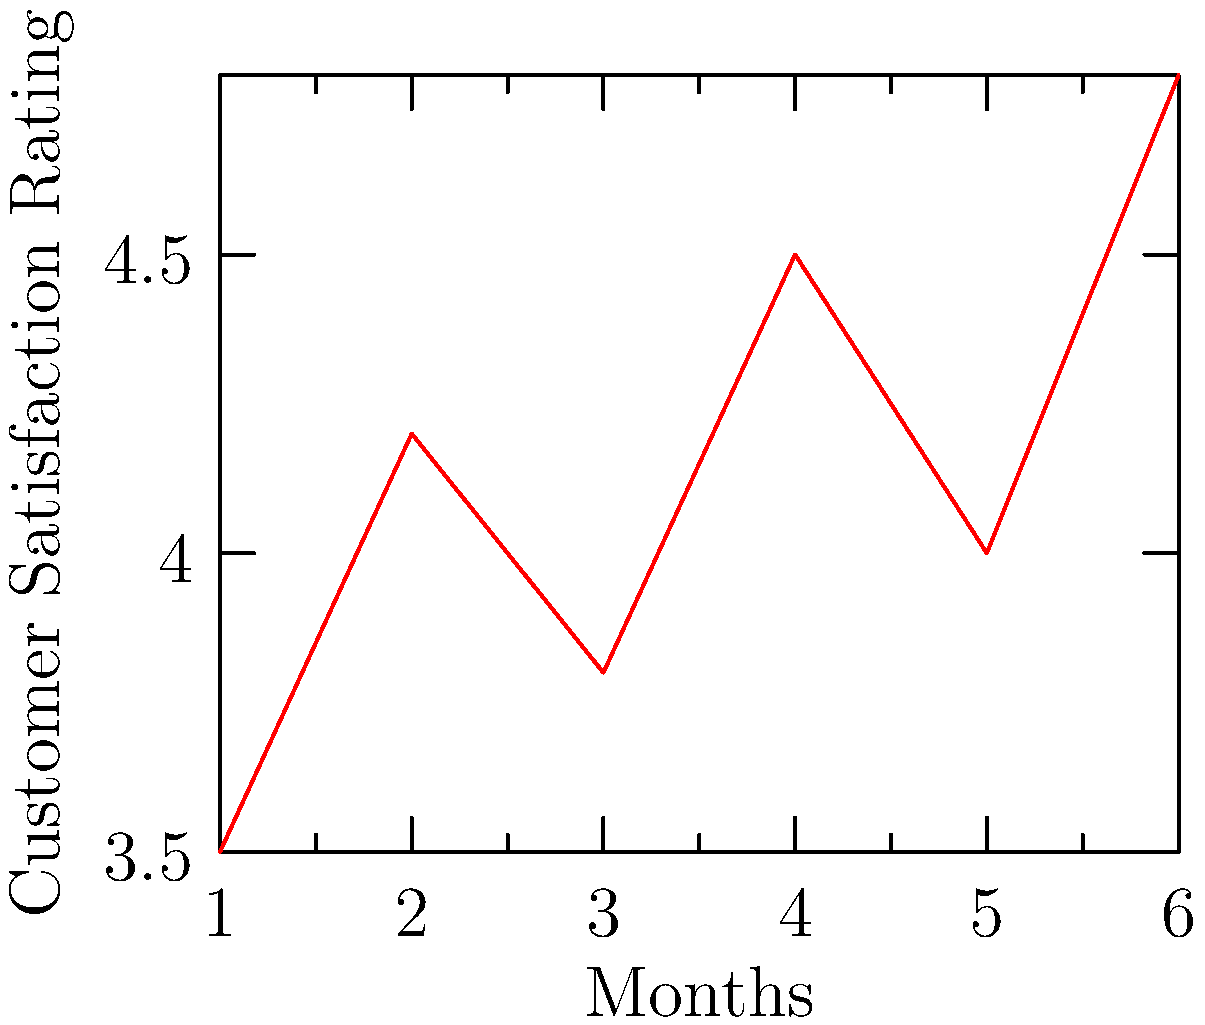As a customer service representative, you are analyzing a line graph showing customer satisfaction ratings over the past 6 months. The ratings are on a scale of 1 to 5, with 5 being the highest. What is the overall trend in customer satisfaction, and what specific action would you recommend to maintain or improve this trend? To answer this question, let's analyze the graph step-by-step:

1. Observe the general trend:
   The line graph shows an overall upward trend from month 1 to month 6.

2. Identify fluctuations:
   There are some ups and downs, but the general direction is positive.

3. Calculate the change from start to end:
   Initial rating (month 1): 3.5
   Final rating (month 6): 4.8
   Overall increase: 4.8 - 3.5 = 1.3 points

4. Interpret the data:
   The customer satisfaction rating has improved significantly over the 6-month period, increasing by 1.3 points on a 5-point scale.

5. Recommend an action:
   To maintain and further improve this positive trend, it would be advisable to:
   a) Analyze what changes or improvements were implemented during this period
   b) Continue and potentially expand successful initiatives
   c) Conduct customer surveys to identify areas for further improvement
   d) Provide additional training to customer service representatives based on successful practices

Given the persona of a new customer service representative, a specific action to recommend would be to implement a regular training program that shares best practices from top-performing representatives, focusing on techniques that have contributed to the improved satisfaction ratings.
Answer: Implement regular training programs sharing best practices from top-performing representatives. 